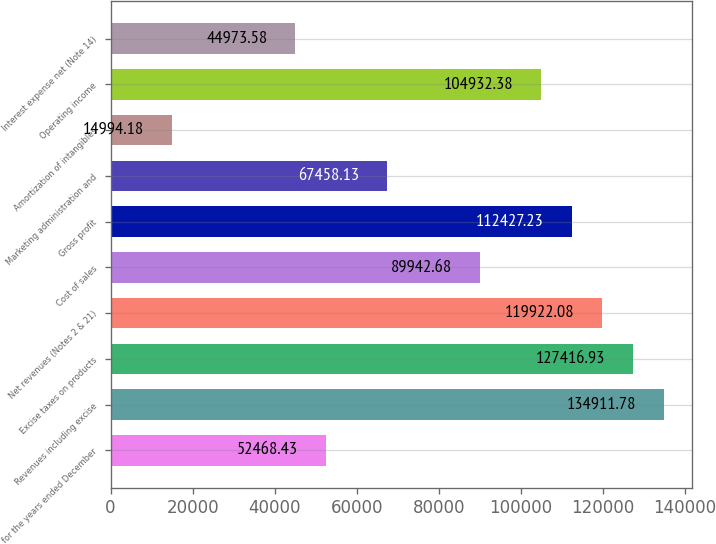<chart> <loc_0><loc_0><loc_500><loc_500><bar_chart><fcel>for the years ended December<fcel>Revenues including excise<fcel>Excise taxes on products<fcel>Net revenues (Notes 2 & 21)<fcel>Cost of sales<fcel>Gross profit<fcel>Marketing administration and<fcel>Amortization of intangibles<fcel>Operating income<fcel>Interest expense net (Note 14)<nl><fcel>52468.4<fcel>134912<fcel>127417<fcel>119922<fcel>89942.7<fcel>112427<fcel>67458.1<fcel>14994.2<fcel>104932<fcel>44973.6<nl></chart> 